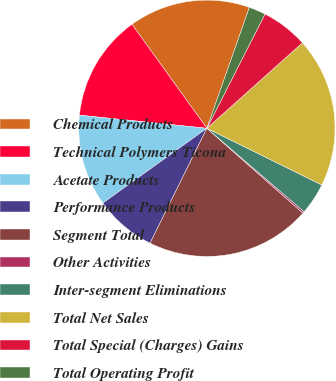Convert chart. <chart><loc_0><loc_0><loc_500><loc_500><pie_chart><fcel>Chemical Products<fcel>Technical Polymers Ticona<fcel>Acetate Products<fcel>Performance Products<fcel>Segment Total<fcel>Other Activities<fcel>Inter-segment Eliminations<fcel>Total Net Sales<fcel>Total Special (Charges) Gains<fcel>Total Operating Profit<nl><fcel>15.32%<fcel>13.43%<fcel>11.55%<fcel>7.77%<fcel>20.79%<fcel>0.23%<fcel>4.0%<fcel>18.91%<fcel>5.89%<fcel>2.11%<nl></chart> 